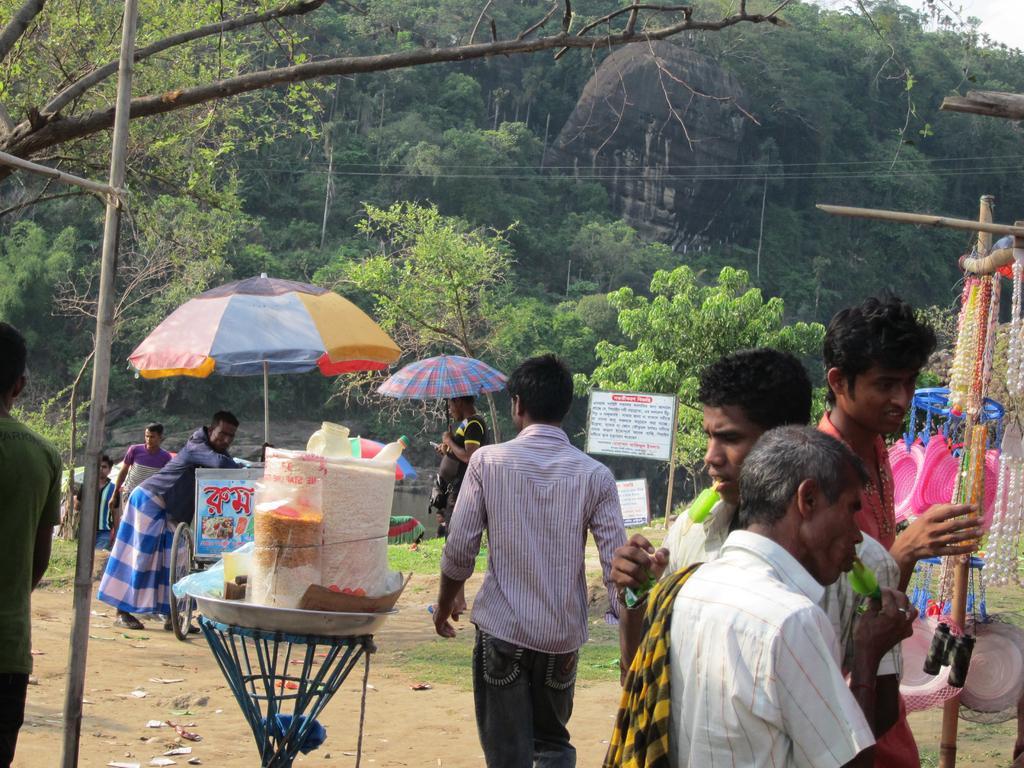Could you give a brief overview of what you see in this image? In this image I can see number of persons are standing on the ground, few wooden poles, few objects hanged to the poles, few umbrellas which are colorful, few persons standing below the umbrella and a white colored board. In the background I can see few trees, a mountain and the sky. 